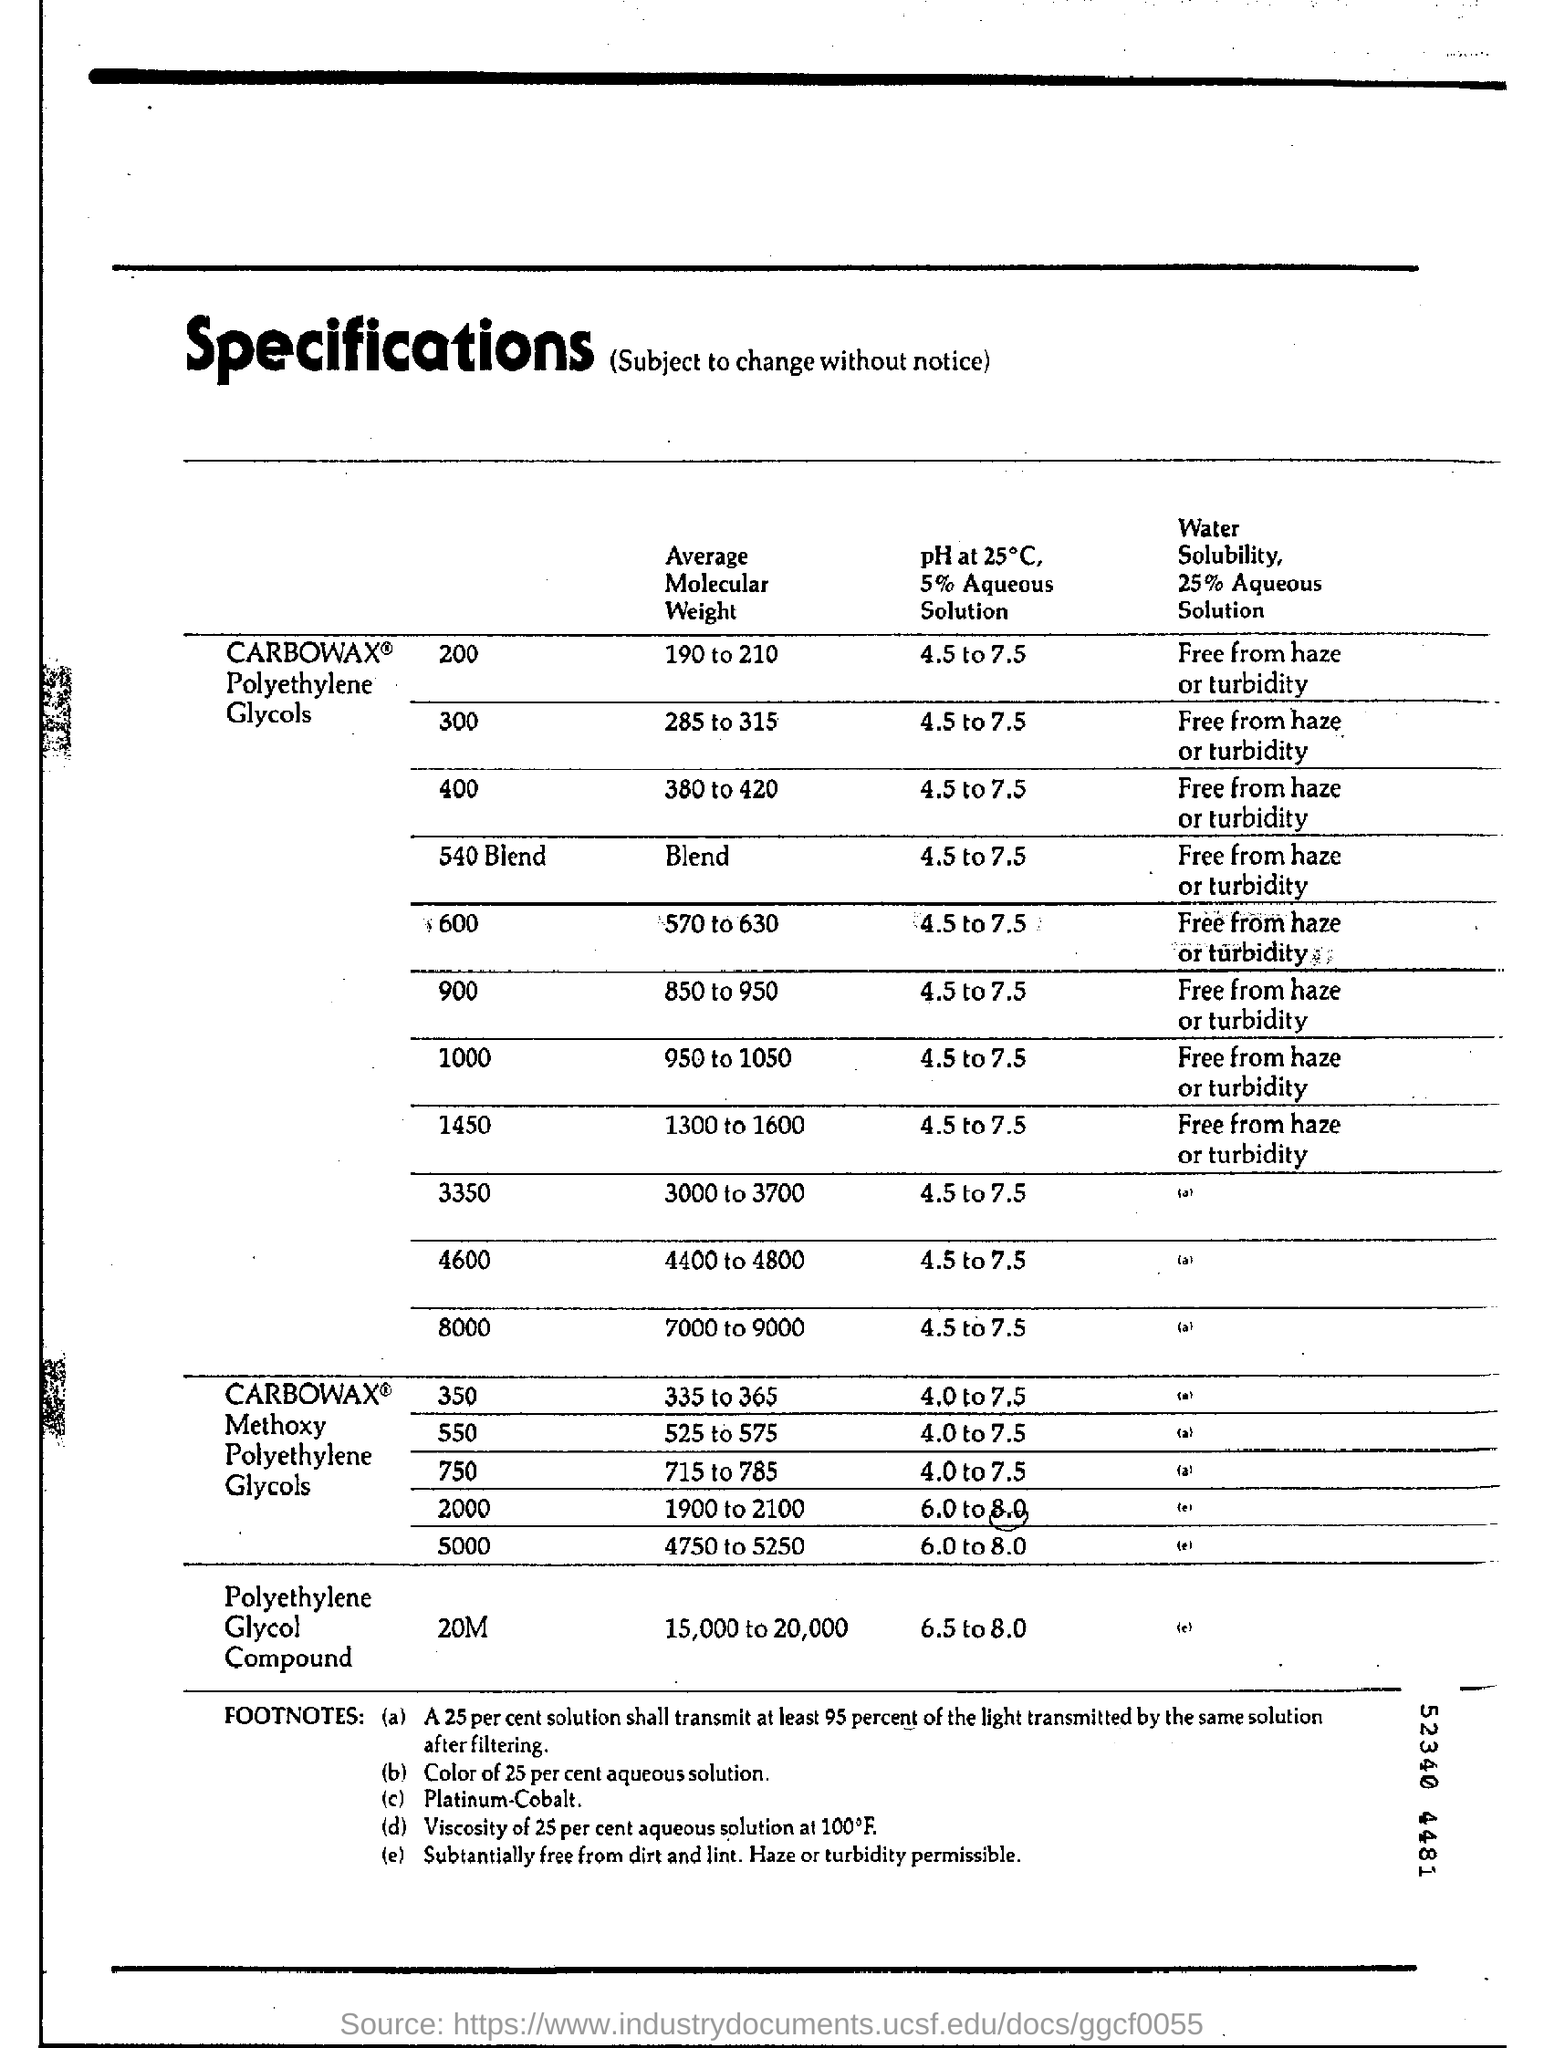List a handful of essential elements in this visual. The average molecular weight of a polyethylene glycol compound ranges from 15,000 to 20,000 to 20,000. 